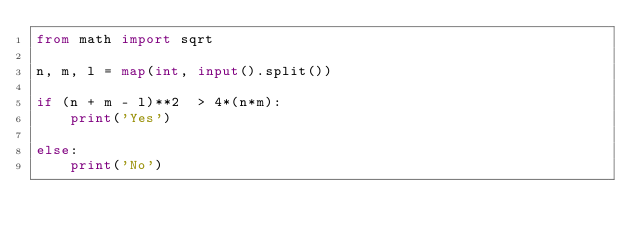<code> <loc_0><loc_0><loc_500><loc_500><_Python_>from math import sqrt

n, m, l = map(int, input().split())

if (n + m - l)**2  > 4*(n*m):
    print('Yes')

else:
    print('No') 
</code> 